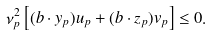<formula> <loc_0><loc_0><loc_500><loc_500>\nu _ { p } ^ { 2 } \left [ ( { b } \cdot { y } _ { p } ) u _ { p } + ( { b } \cdot { z } _ { p } ) v _ { p } \right ] \leq 0 .</formula> 